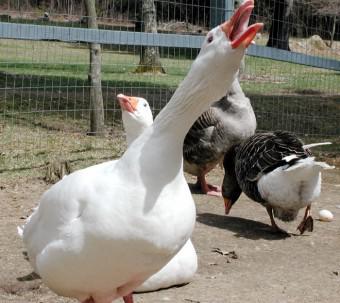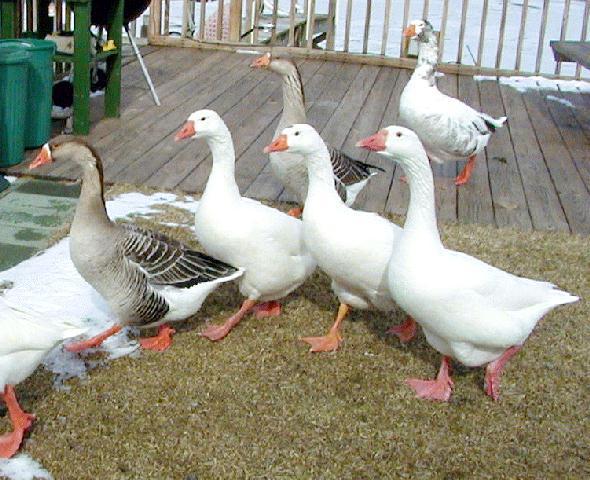The first image is the image on the left, the second image is the image on the right. For the images shown, is this caption "There are 6 or more completely white geese." true? Answer yes or no. Yes. 